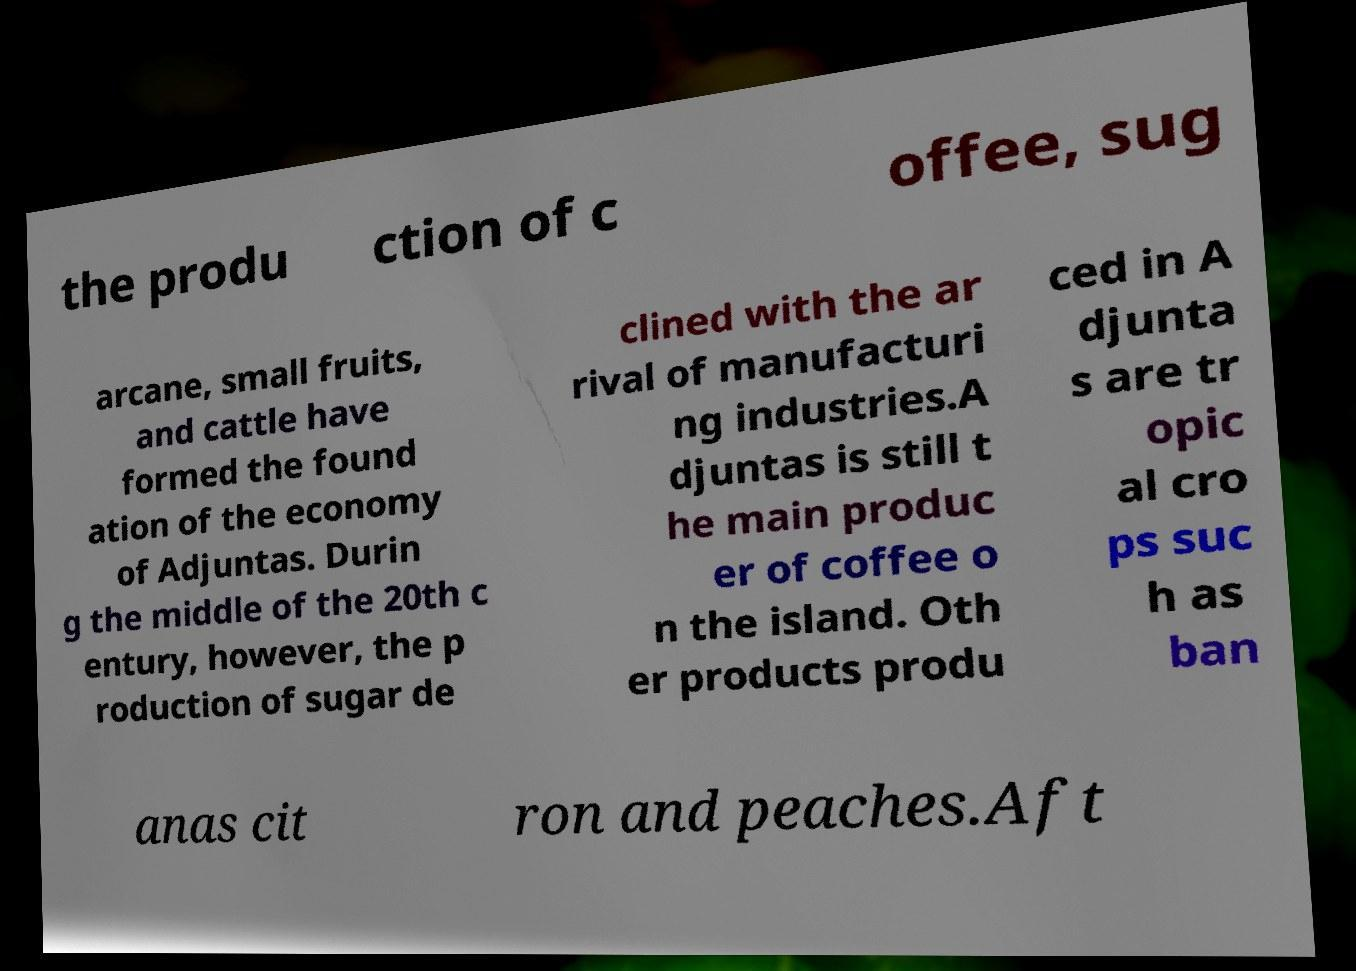What messages or text are displayed in this image? I need them in a readable, typed format. the produ ction of c offee, sug arcane, small fruits, and cattle have formed the found ation of the economy of Adjuntas. Durin g the middle of the 20th c entury, however, the p roduction of sugar de clined with the ar rival of manufacturi ng industries.A djuntas is still t he main produc er of coffee o n the island. Oth er products produ ced in A djunta s are tr opic al cro ps suc h as ban anas cit ron and peaches.Aft 